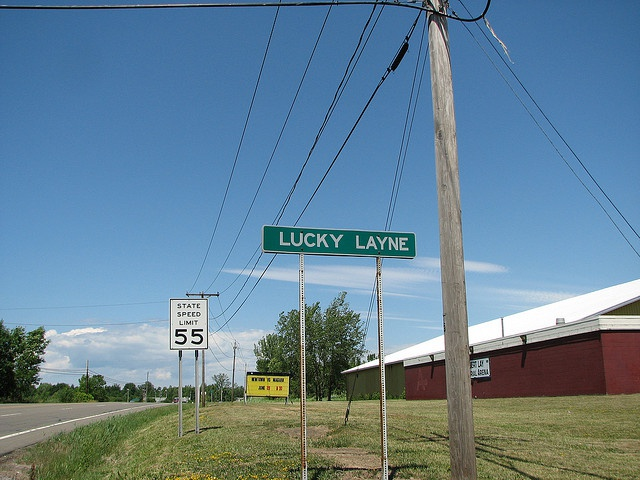Describe the objects in this image and their specific colors. I can see various objects in this image with different colors. 